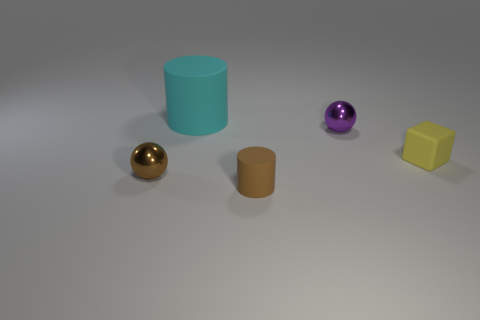Add 4 matte blocks. How many objects exist? 9 Subtract all spheres. How many objects are left? 3 Subtract 0 cyan balls. How many objects are left? 5 Subtract all tiny shiny objects. Subtract all small brown metal things. How many objects are left? 2 Add 3 spheres. How many spheres are left? 5 Add 4 rubber blocks. How many rubber blocks exist? 5 